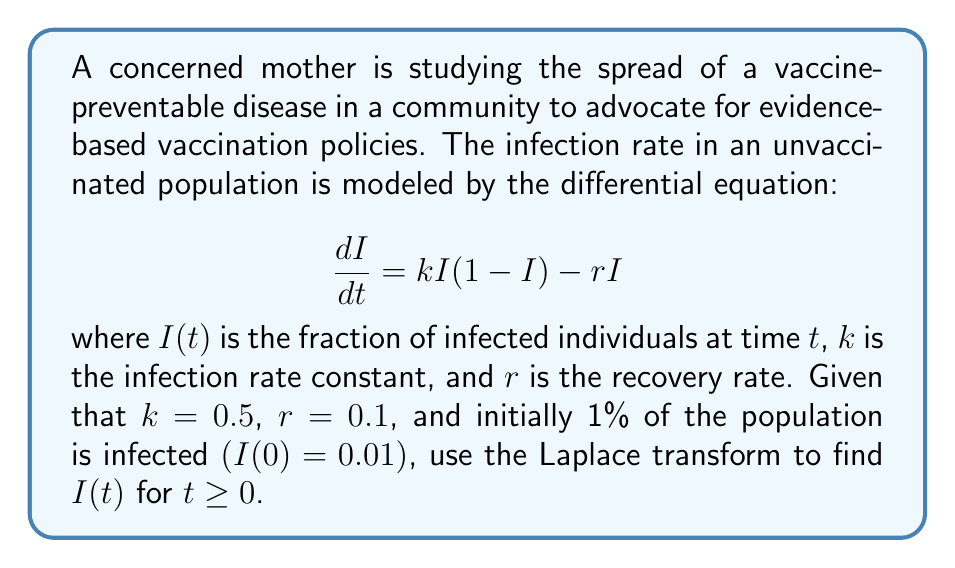Show me your answer to this math problem. To solve this problem using Laplace transform techniques, we'll follow these steps:

1) First, let's rewrite the differential equation:
   $$\frac{dI}{dt} = 0.5I(1-I) - 0.1I = 0.5I - 0.5I^2 - 0.1I = 0.4I - 0.5I^2$$

2) Now, let's apply the Laplace transform to both sides. Let $\mathcal{L}\{I(t)\} = Y(s)$:
   $$\mathcal{L}\{\frac{dI}{dt}\} = \mathcal{L}\{0.4I - 0.5I^2\}$$

3) Using Laplace transform properties:
   $$sY(s) - I(0) = 0.4Y(s) - 0.5\mathcal{L}\{I^2\}$$

4) The Laplace transform of $I^2$ is challenging to compute directly. We can use the fact that for small $I$, $I^2 \approx 0$. This approximation is reasonable given the initial condition $I(0) = 0.01$. With this approximation:
   $$sY(s) - 0.01 = 0.4Y(s)$$

5) Rearranging terms:
   $$(s - 0.4)Y(s) = 0.01$$

6) Solving for $Y(s)$:
   $$Y(s) = \frac{0.01}{s - 0.4}$$

7) This can be inverse transformed using the formula $\mathcal{L}^{-1}\{\frac{a}{s-b}\} = ae^{bt}$:
   $$I(t) = 0.01e^{0.4t}$$

This solution represents exponential growth of the infection, which is expected in the early stages of an epidemic when $I$ is small.
Answer: $I(t) = 0.01e^{0.4t}$ for $t \geq 0$ 